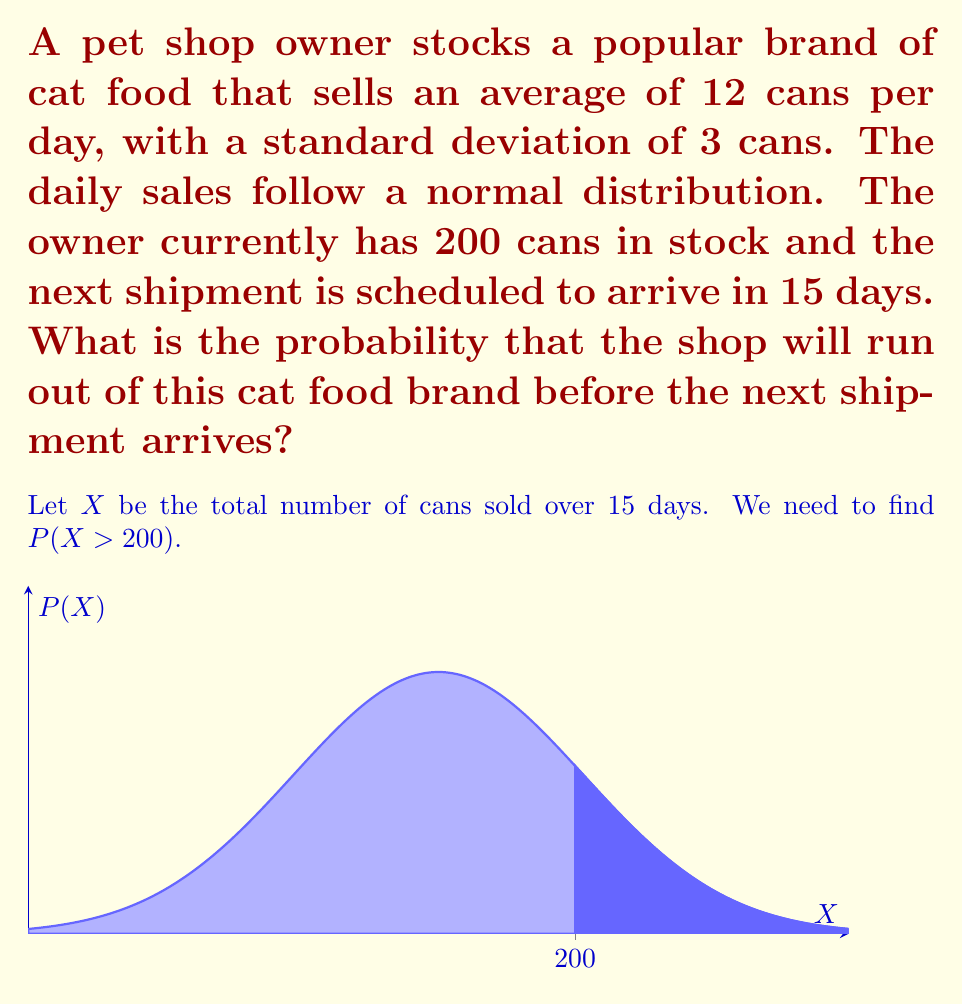Teach me how to tackle this problem. Let's approach this step-by-step:

1) First, we need to find the mean and standard deviation for the 15-day period:

   Mean (μ) = 12 cans/day * 15 days = 180 cans
   Standard deviation (σ) = $3 \sqrt{15} \approx 11.62$ cans

   We use $\sqrt{15}$ because variances add for independent normal variables.

2) Now, we want to find P(X > 200), where X ~ N(180, 11.62²)

3) We can standardize this to a Z-score:

   $Z = \frac{X - \mu}{\sigma} = \frac{200 - 180}{11.62} \approx 1.72$

4) We want P(Z > 1.72)

5) Using a standard normal table or calculator, we can find:
   P(Z < 1.72) ≈ 0.9573

6) Therefore, P(Z > 1.72) = 1 - 0.9573 = 0.0427

This means there's approximately a 4.27% chance of running out of stock before the next shipment.
Answer: 0.0427 or 4.27% 